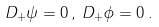<formula> <loc_0><loc_0><loc_500><loc_500>D _ { + } \psi = 0 \, , \, D _ { + } \phi = 0 \, .</formula> 